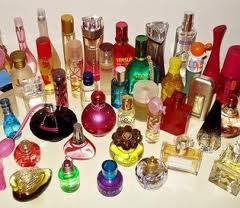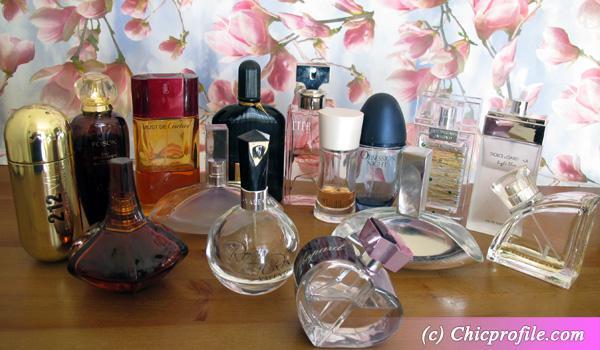The first image is the image on the left, the second image is the image on the right. Assess this claim about the two images: "Every image has more than nine fragrances.". Correct or not? Answer yes or no. Yes. The first image is the image on the left, the second image is the image on the right. Analyze the images presented: Is the assertion "A heart-shaped clear glass bottle is in the front of a grouping of different fragrance bottles." valid? Answer yes or no. Yes. 